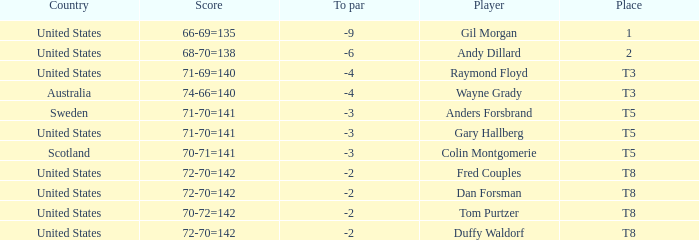What is the T8 Place Player? Fred Couples, Dan Forsman, Tom Purtzer, Duffy Waldorf. 